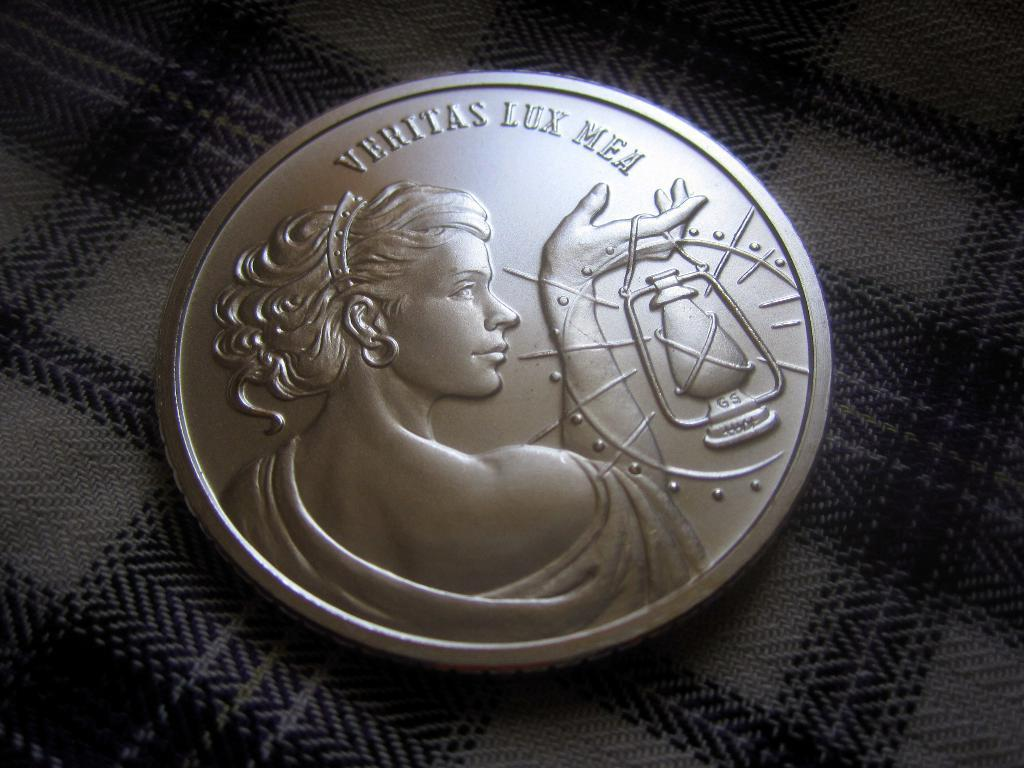Provide a one-sentence caption for the provided image. A coin that says "veritas lux mea" features a woman with a lantern. 